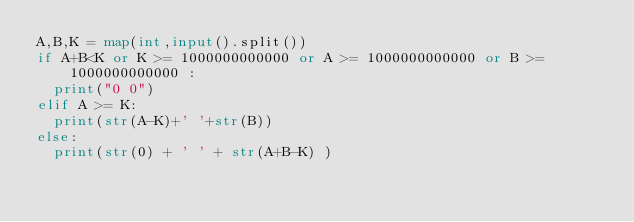<code> <loc_0><loc_0><loc_500><loc_500><_Python_>A,B,K = map(int,input().split())
if A+B<K or K >= 1000000000000 or A >= 1000000000000 or B >= 1000000000000 :
  print("0 0")
elif A >= K:
  print(str(A-K)+' '+str(B))
else:
  print(str(0) + ' ' + str(A+B-K) )
  </code> 